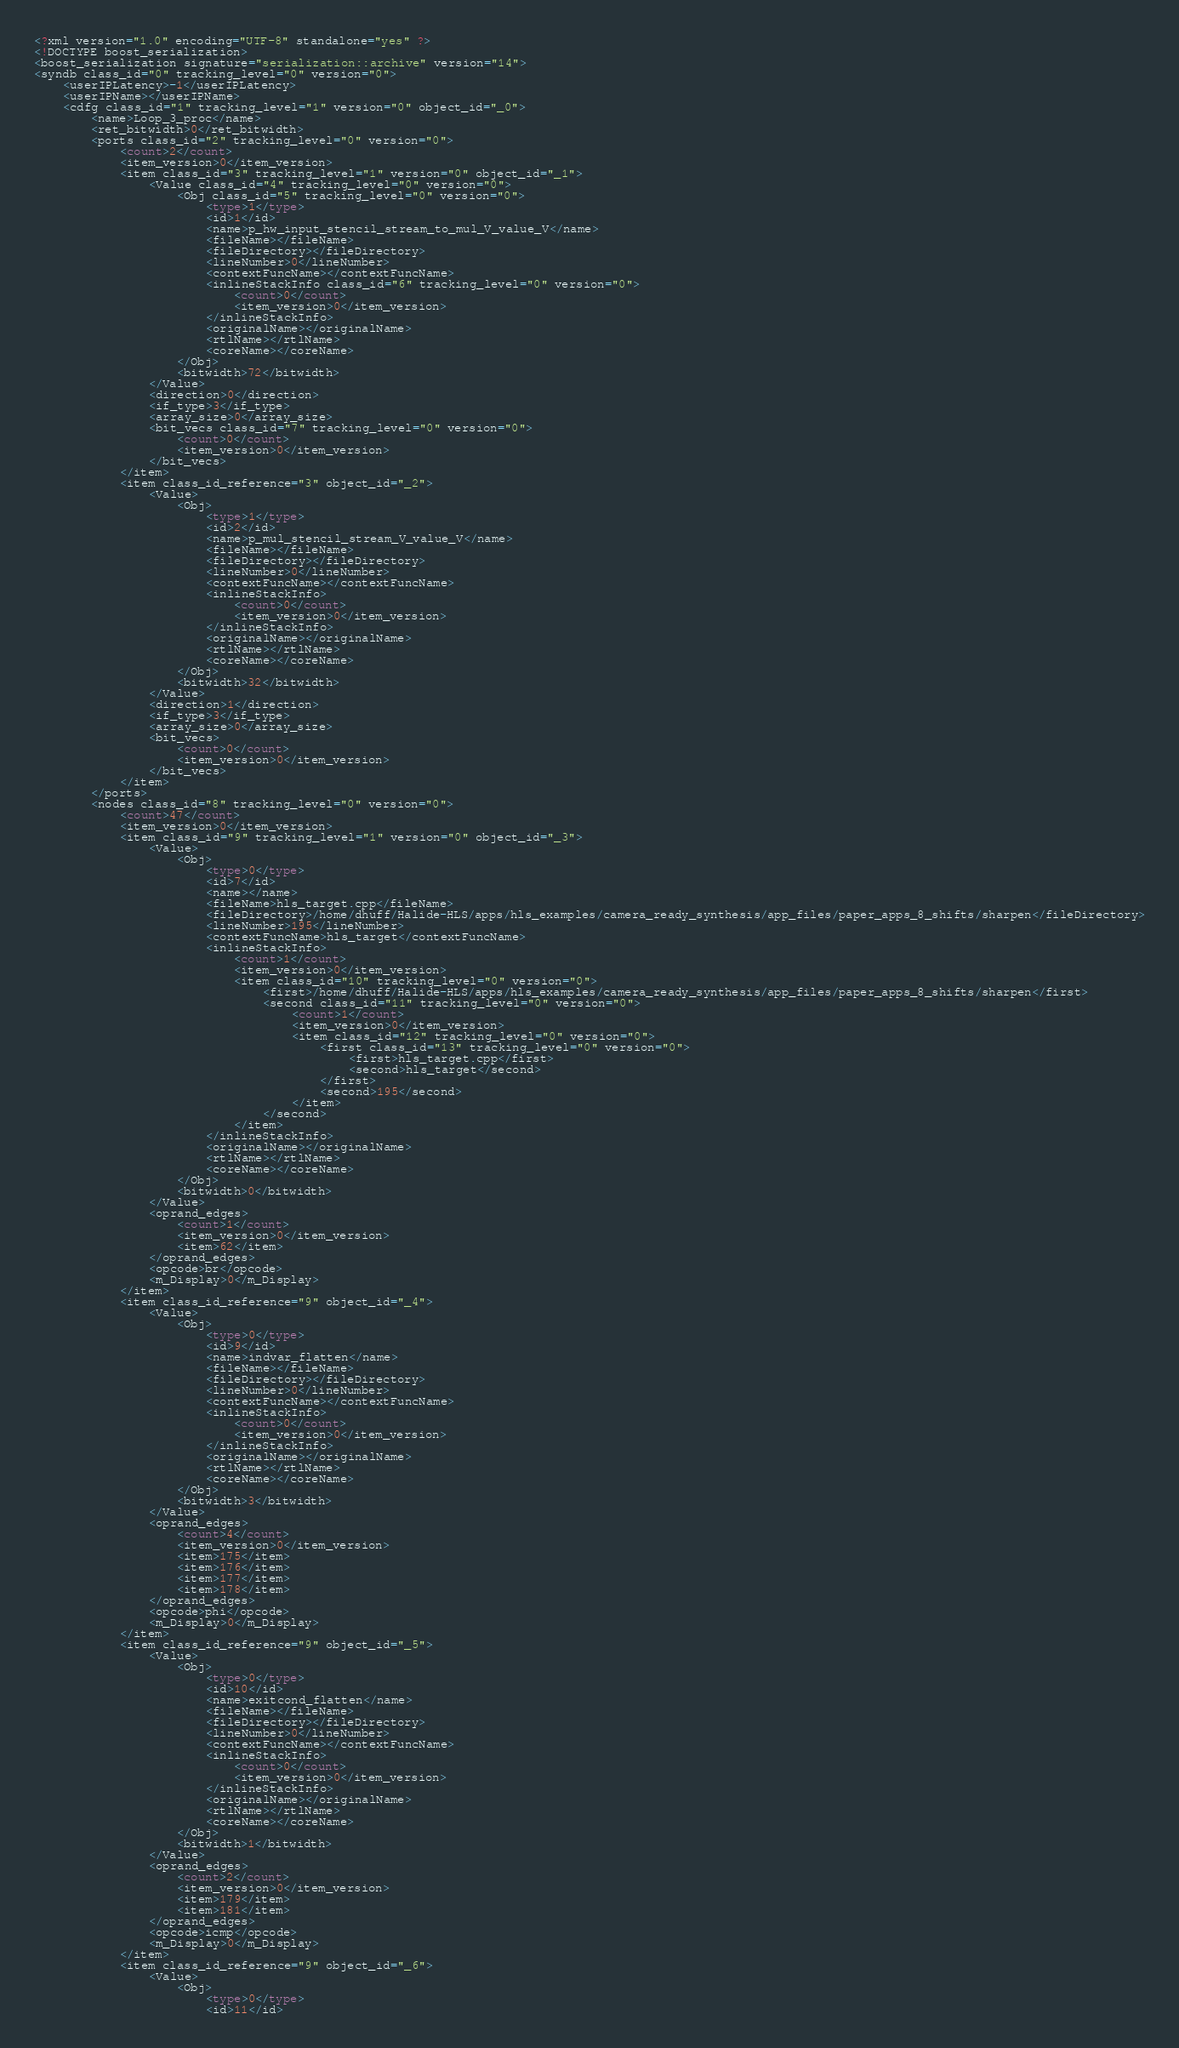<code> <loc_0><loc_0><loc_500><loc_500><_Ada_><?xml version="1.0" encoding="UTF-8" standalone="yes" ?>
<!DOCTYPE boost_serialization>
<boost_serialization signature="serialization::archive" version="14">
<syndb class_id="0" tracking_level="0" version="0">
	<userIPLatency>-1</userIPLatency>
	<userIPName></userIPName>
	<cdfg class_id="1" tracking_level="1" version="0" object_id="_0">
		<name>Loop_3_proc</name>
		<ret_bitwidth>0</ret_bitwidth>
		<ports class_id="2" tracking_level="0" version="0">
			<count>2</count>
			<item_version>0</item_version>
			<item class_id="3" tracking_level="1" version="0" object_id="_1">
				<Value class_id="4" tracking_level="0" version="0">
					<Obj class_id="5" tracking_level="0" version="0">
						<type>1</type>
						<id>1</id>
						<name>p_hw_input_stencil_stream_to_mul_V_value_V</name>
						<fileName></fileName>
						<fileDirectory></fileDirectory>
						<lineNumber>0</lineNumber>
						<contextFuncName></contextFuncName>
						<inlineStackInfo class_id="6" tracking_level="0" version="0">
							<count>0</count>
							<item_version>0</item_version>
						</inlineStackInfo>
						<originalName></originalName>
						<rtlName></rtlName>
						<coreName></coreName>
					</Obj>
					<bitwidth>72</bitwidth>
				</Value>
				<direction>0</direction>
				<if_type>3</if_type>
				<array_size>0</array_size>
				<bit_vecs class_id="7" tracking_level="0" version="0">
					<count>0</count>
					<item_version>0</item_version>
				</bit_vecs>
			</item>
			<item class_id_reference="3" object_id="_2">
				<Value>
					<Obj>
						<type>1</type>
						<id>2</id>
						<name>p_mul_stencil_stream_V_value_V</name>
						<fileName></fileName>
						<fileDirectory></fileDirectory>
						<lineNumber>0</lineNumber>
						<contextFuncName></contextFuncName>
						<inlineStackInfo>
							<count>0</count>
							<item_version>0</item_version>
						</inlineStackInfo>
						<originalName></originalName>
						<rtlName></rtlName>
						<coreName></coreName>
					</Obj>
					<bitwidth>32</bitwidth>
				</Value>
				<direction>1</direction>
				<if_type>3</if_type>
				<array_size>0</array_size>
				<bit_vecs>
					<count>0</count>
					<item_version>0</item_version>
				</bit_vecs>
			</item>
		</ports>
		<nodes class_id="8" tracking_level="0" version="0">
			<count>47</count>
			<item_version>0</item_version>
			<item class_id="9" tracking_level="1" version="0" object_id="_3">
				<Value>
					<Obj>
						<type>0</type>
						<id>7</id>
						<name></name>
						<fileName>hls_target.cpp</fileName>
						<fileDirectory>/home/dhuff/Halide-HLS/apps/hls_examples/camera_ready_synthesis/app_files/paper_apps_8_shifts/sharpen</fileDirectory>
						<lineNumber>195</lineNumber>
						<contextFuncName>hls_target</contextFuncName>
						<inlineStackInfo>
							<count>1</count>
							<item_version>0</item_version>
							<item class_id="10" tracking_level="0" version="0">
								<first>/home/dhuff/Halide-HLS/apps/hls_examples/camera_ready_synthesis/app_files/paper_apps_8_shifts/sharpen</first>
								<second class_id="11" tracking_level="0" version="0">
									<count>1</count>
									<item_version>0</item_version>
									<item class_id="12" tracking_level="0" version="0">
										<first class_id="13" tracking_level="0" version="0">
											<first>hls_target.cpp</first>
											<second>hls_target</second>
										</first>
										<second>195</second>
									</item>
								</second>
							</item>
						</inlineStackInfo>
						<originalName></originalName>
						<rtlName></rtlName>
						<coreName></coreName>
					</Obj>
					<bitwidth>0</bitwidth>
				</Value>
				<oprand_edges>
					<count>1</count>
					<item_version>0</item_version>
					<item>62</item>
				</oprand_edges>
				<opcode>br</opcode>
				<m_Display>0</m_Display>
			</item>
			<item class_id_reference="9" object_id="_4">
				<Value>
					<Obj>
						<type>0</type>
						<id>9</id>
						<name>indvar_flatten</name>
						<fileName></fileName>
						<fileDirectory></fileDirectory>
						<lineNumber>0</lineNumber>
						<contextFuncName></contextFuncName>
						<inlineStackInfo>
							<count>0</count>
							<item_version>0</item_version>
						</inlineStackInfo>
						<originalName></originalName>
						<rtlName></rtlName>
						<coreName></coreName>
					</Obj>
					<bitwidth>3</bitwidth>
				</Value>
				<oprand_edges>
					<count>4</count>
					<item_version>0</item_version>
					<item>175</item>
					<item>176</item>
					<item>177</item>
					<item>178</item>
				</oprand_edges>
				<opcode>phi</opcode>
				<m_Display>0</m_Display>
			</item>
			<item class_id_reference="9" object_id="_5">
				<Value>
					<Obj>
						<type>0</type>
						<id>10</id>
						<name>exitcond_flatten</name>
						<fileName></fileName>
						<fileDirectory></fileDirectory>
						<lineNumber>0</lineNumber>
						<contextFuncName></contextFuncName>
						<inlineStackInfo>
							<count>0</count>
							<item_version>0</item_version>
						</inlineStackInfo>
						<originalName></originalName>
						<rtlName></rtlName>
						<coreName></coreName>
					</Obj>
					<bitwidth>1</bitwidth>
				</Value>
				<oprand_edges>
					<count>2</count>
					<item_version>0</item_version>
					<item>179</item>
					<item>181</item>
				</oprand_edges>
				<opcode>icmp</opcode>
				<m_Display>0</m_Display>
			</item>
			<item class_id_reference="9" object_id="_6">
				<Value>
					<Obj>
						<type>0</type>
						<id>11</id></code> 